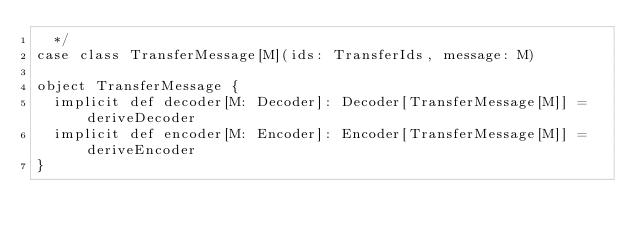<code> <loc_0><loc_0><loc_500><loc_500><_Scala_>  */
case class TransferMessage[M](ids: TransferIds, message: M)

object TransferMessage {
  implicit def decoder[M: Decoder]: Decoder[TransferMessage[M]] = deriveDecoder
  implicit def encoder[M: Encoder]: Encoder[TransferMessage[M]] = deriveEncoder
}
</code> 